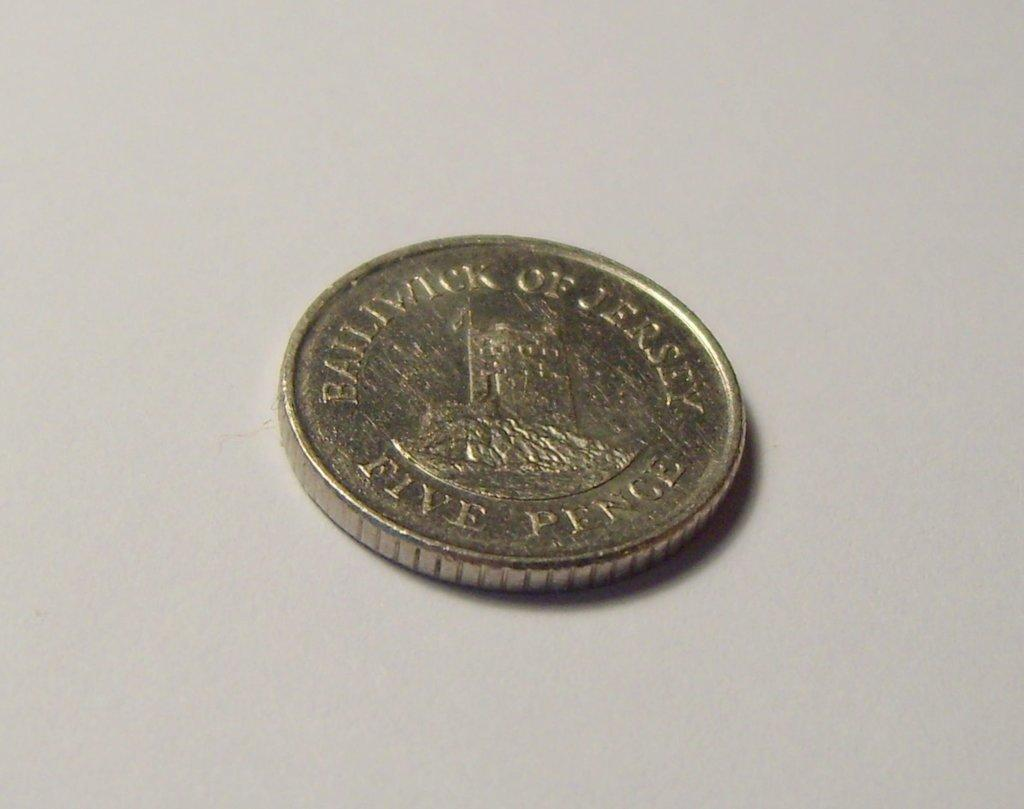What is the main subject of the image? There is a coin in the center of the image. What color is the background of the image? The background of the image is white. How many cacti are visible in the image? There are no cacti present in the image; it only features a coin on a white background. 